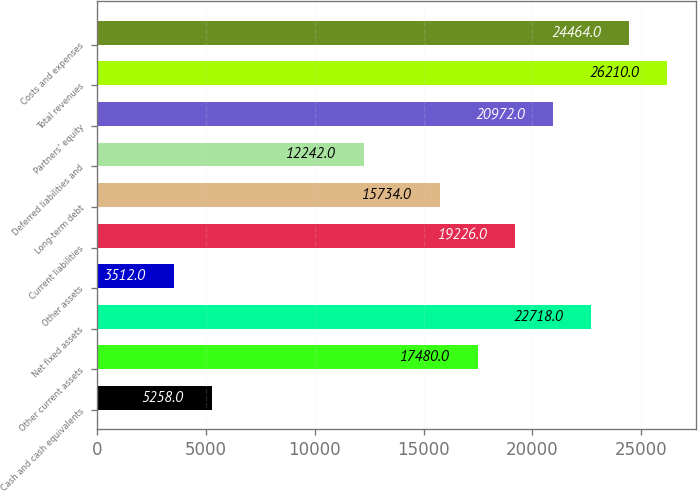Convert chart. <chart><loc_0><loc_0><loc_500><loc_500><bar_chart><fcel>Cash and cash equivalents<fcel>Other current assets<fcel>Net fixed assets<fcel>Other assets<fcel>Current liabilities<fcel>Long-term debt<fcel>Deferred liabilities and<fcel>Partners' equity<fcel>Total revenues<fcel>Costs and expenses<nl><fcel>5258<fcel>17480<fcel>22718<fcel>3512<fcel>19226<fcel>15734<fcel>12242<fcel>20972<fcel>26210<fcel>24464<nl></chart> 